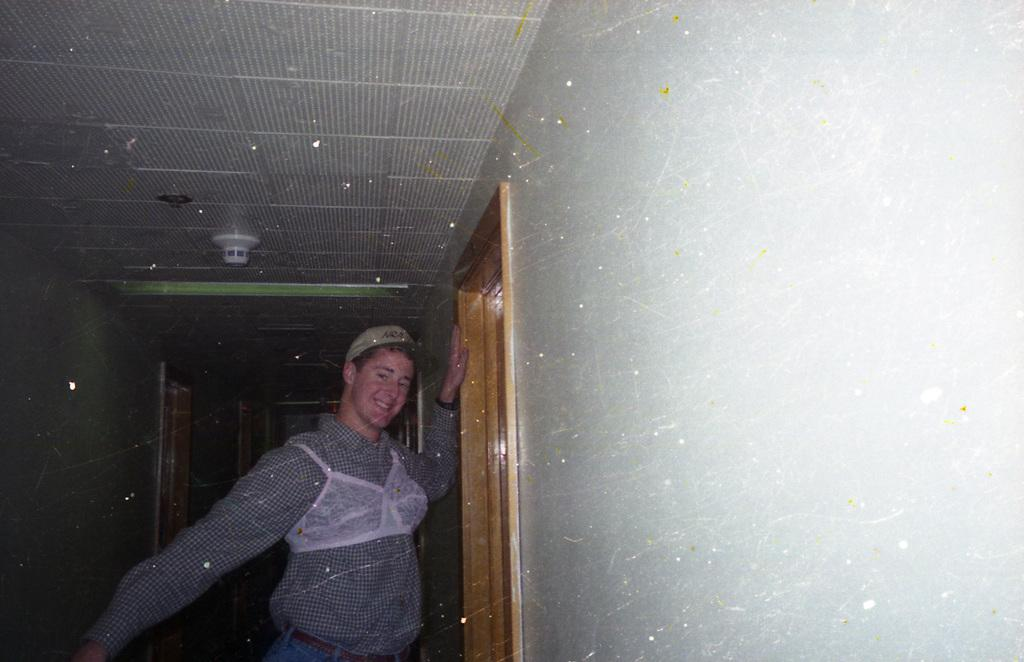What is the person in the image doing? The person is standing in the image and smiling. What can be seen in the background of the image? There are doors and a wall visible in the image. What is located at the top of the image? There are lights at the top of the image. What type of summer clothing is the person wearing in the image? The provided facts do not mention any clothing or season, so we cannot determine the type of summer clothing the person is wearing. 